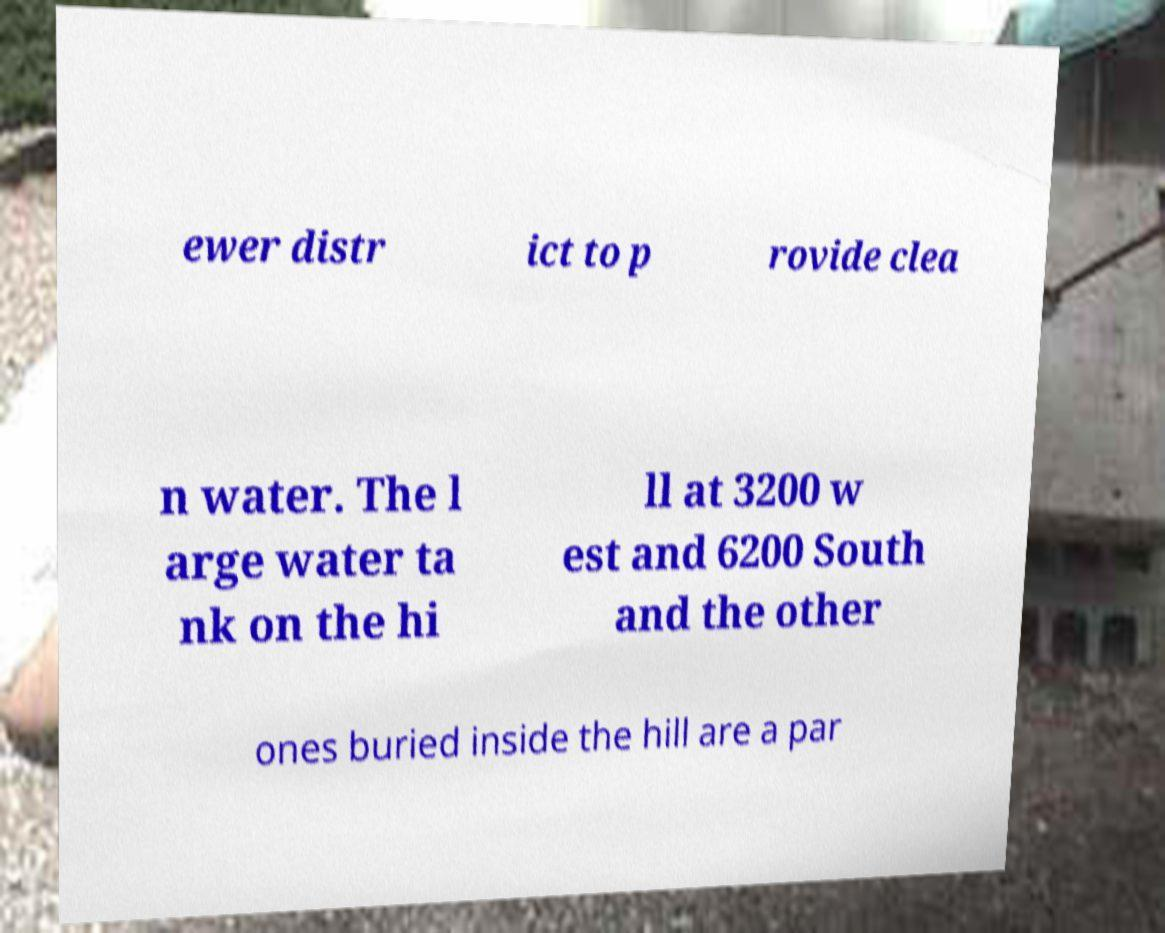There's text embedded in this image that I need extracted. Can you transcribe it verbatim? ewer distr ict to p rovide clea n water. The l arge water ta nk on the hi ll at 3200 w est and 6200 South and the other ones buried inside the hill are a par 